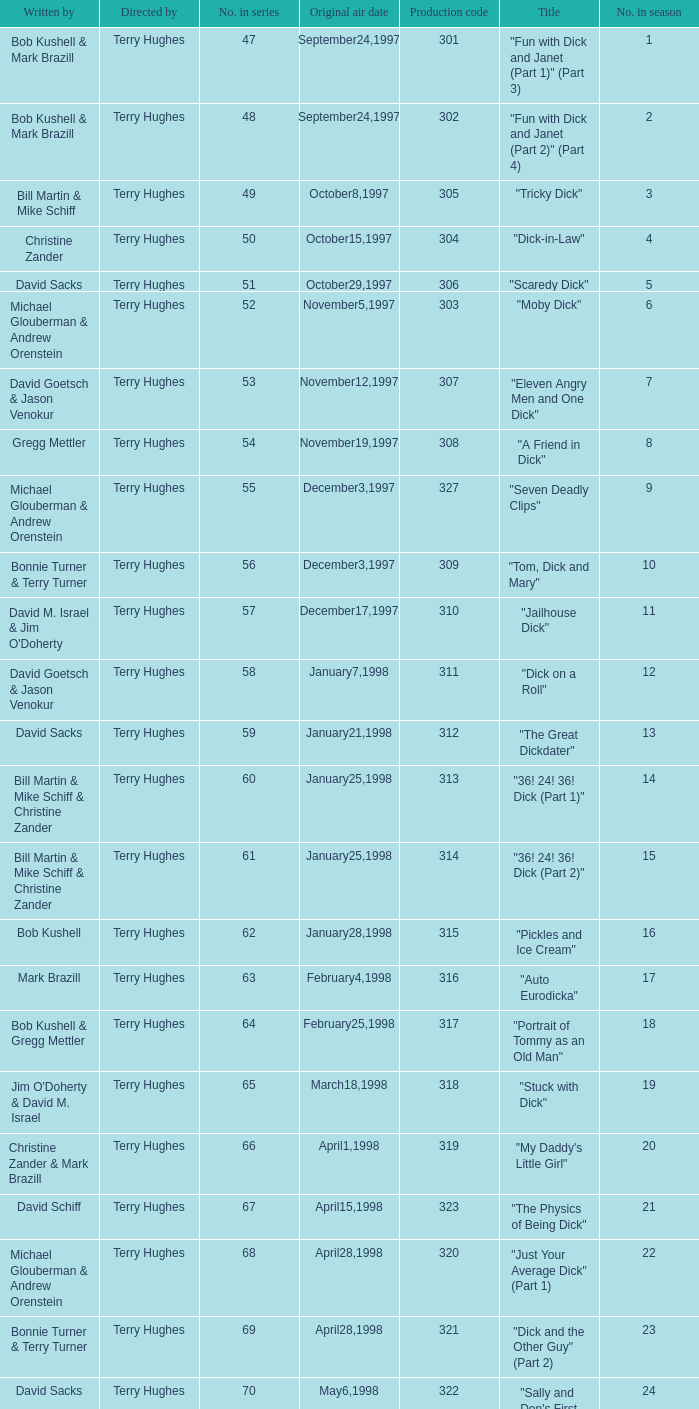What is the title of episode 10? "Tom, Dick and Mary". 